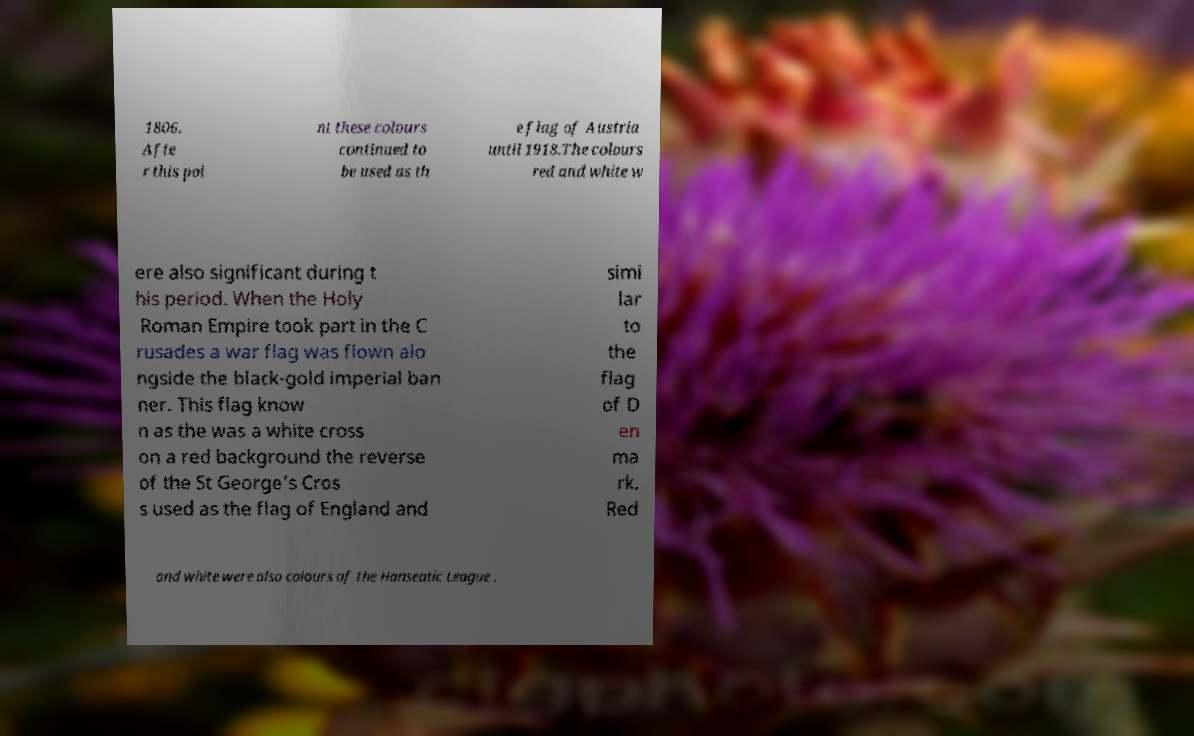Could you extract and type out the text from this image? 1806. Afte r this poi nt these colours continued to be used as th e flag of Austria until 1918.The colours red and white w ere also significant during t his period. When the Holy Roman Empire took part in the C rusades a war flag was flown alo ngside the black-gold imperial ban ner. This flag know n as the was a white cross on a red background the reverse of the St George's Cros s used as the flag of England and simi lar to the flag of D en ma rk. Red and white were also colours of the Hanseatic League . 